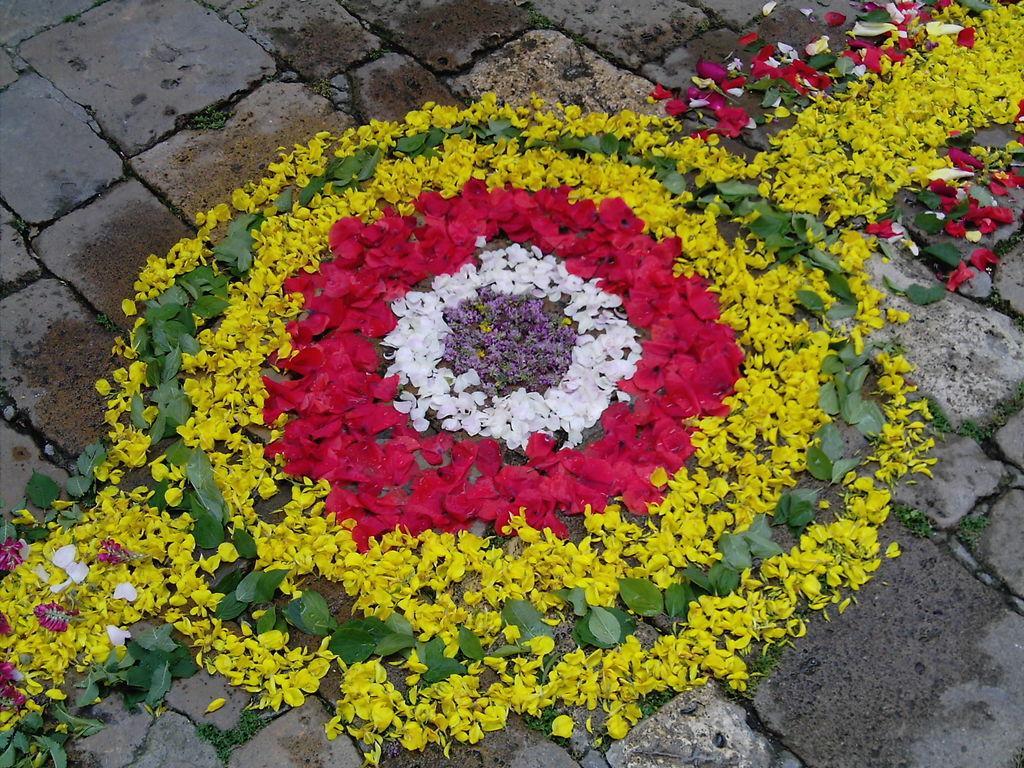Please provide a concise description of this image. In the picture I can see few flowers which are in different colors are placed on the ground. 